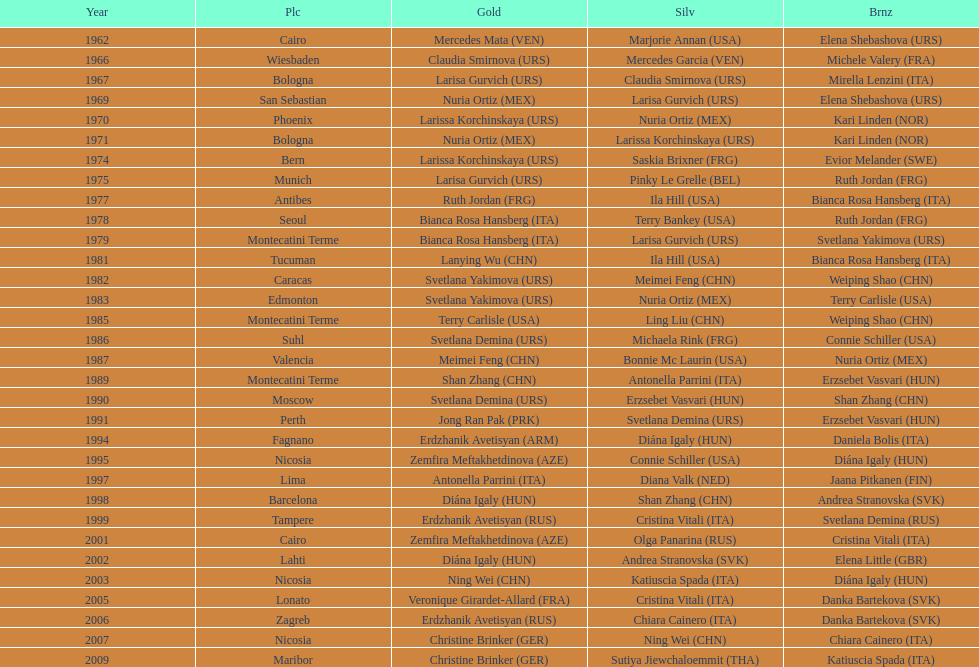Which country has won more gold medals: china or mexico? China. 